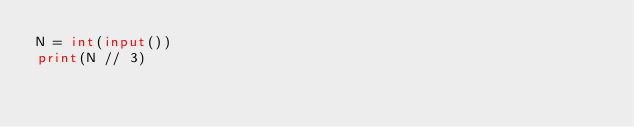<code> <loc_0><loc_0><loc_500><loc_500><_Python_>N = int(input())
print(N // 3)
</code> 